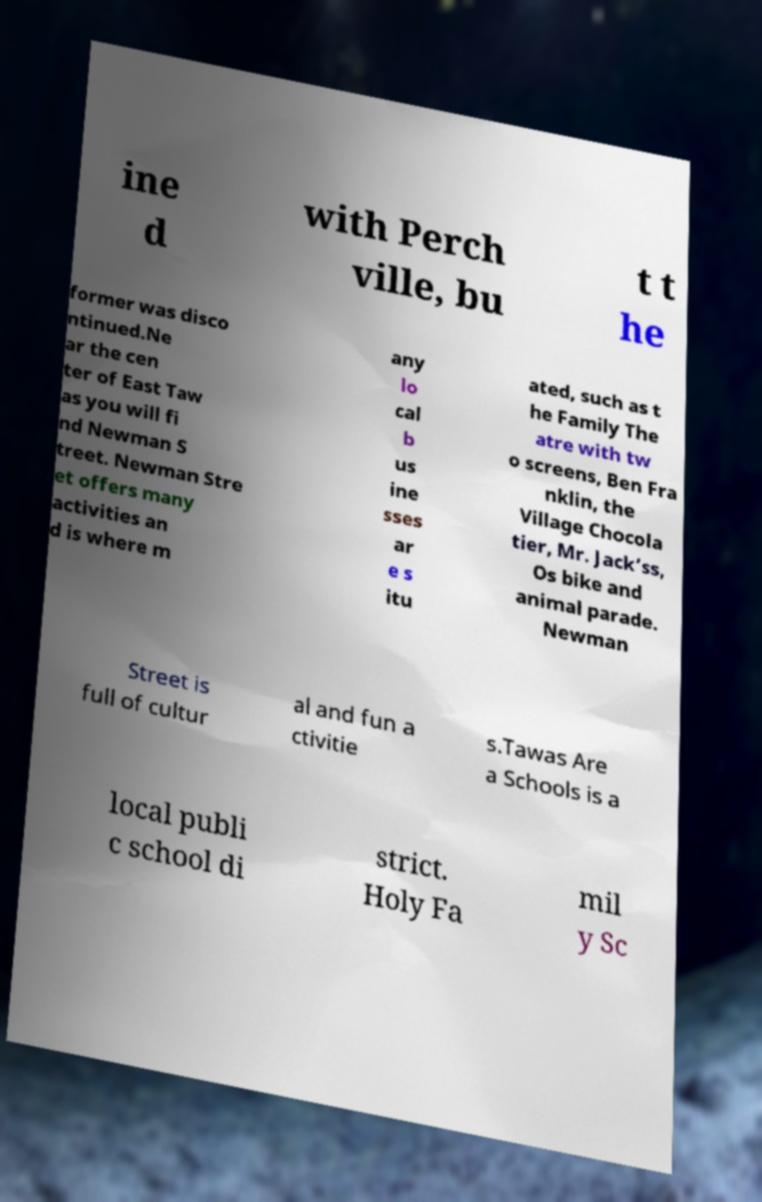Could you extract and type out the text from this image? ine d with Perch ville, bu t t he former was disco ntinued.Ne ar the cen ter of East Taw as you will fi nd Newman S treet. Newman Stre et offers many activities an d is where m any lo cal b us ine sses ar e s itu ated, such as t he Family The atre with tw o screens, Ben Fra nklin, the Village Chocola tier, Mr. Jack’ss, Os bike and animal parade. Newman Street is full of cultur al and fun a ctivitie s.Tawas Are a Schools is a local publi c school di strict. Holy Fa mil y Sc 